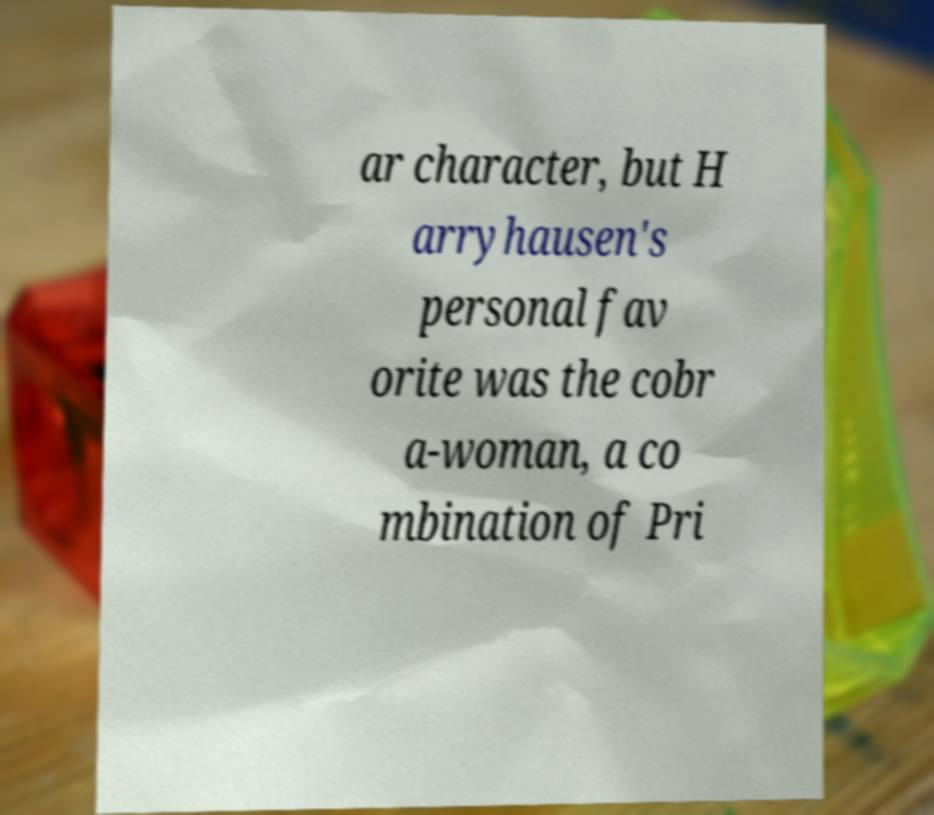What messages or text are displayed in this image? I need them in a readable, typed format. ar character, but H arryhausen's personal fav orite was the cobr a-woman, a co mbination of Pri 